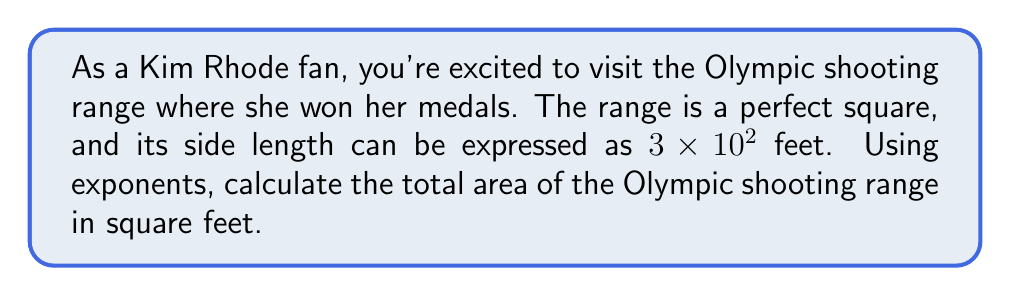Give your solution to this math problem. To solve this problem, let's break it down into steps:

1) First, we need to understand what the side length of the range is:
   $3 \times 10^2$ feet = 300 feet

2) Since the range is a perfect square, we can calculate the area using the formula:
   $A = s^2$, where $A$ is the area and $s$ is the side length

3) Substituting our side length:
   $A = (3 \times 10^2)^2$

4) To solve this, we can use the properties of exponents:
   $(a \times 10^n)^2 = a^2 \times 10^{2n}$

5) Applying this to our problem:
   $A = 3^2 \times (10^2)^2$

6) Simplify:
   $A = 9 \times 10^4$

7) Calculate:
   $A = 90,000$ square feet

Therefore, the area of the Olympic shooting range is $9 \times 10^4$ or 90,000 square feet.
Answer: $9 \times 10^4$ square feet 